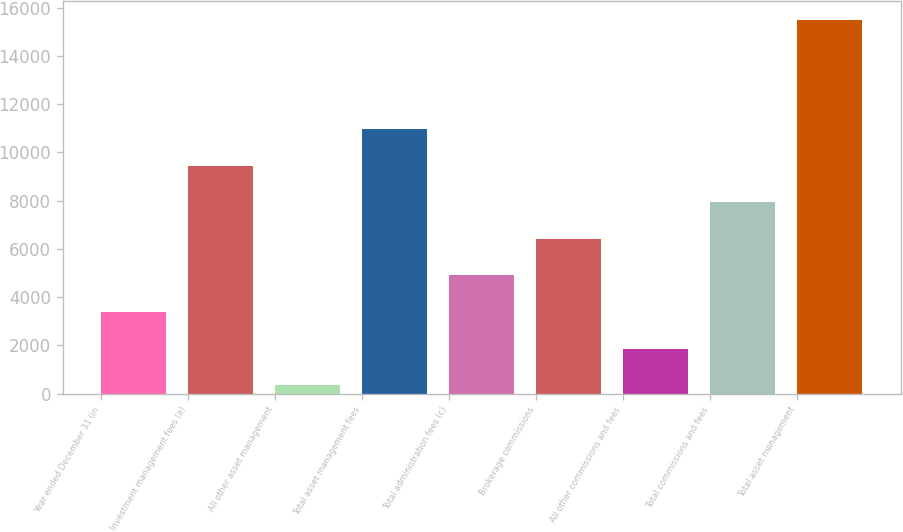Convert chart. <chart><loc_0><loc_0><loc_500><loc_500><bar_chart><fcel>Year ended December 31 (in<fcel>Investment management fees (a)<fcel>All other asset management<fcel>Total asset management fees<fcel>Total administration fees (c)<fcel>Brokerage commissions<fcel>All other commissions and fees<fcel>Total commissions and fees<fcel>Total asset management<nl><fcel>3383.4<fcel>9446.2<fcel>352<fcel>10961.9<fcel>4899.1<fcel>6414.8<fcel>1867.7<fcel>7930.5<fcel>15509<nl></chart> 